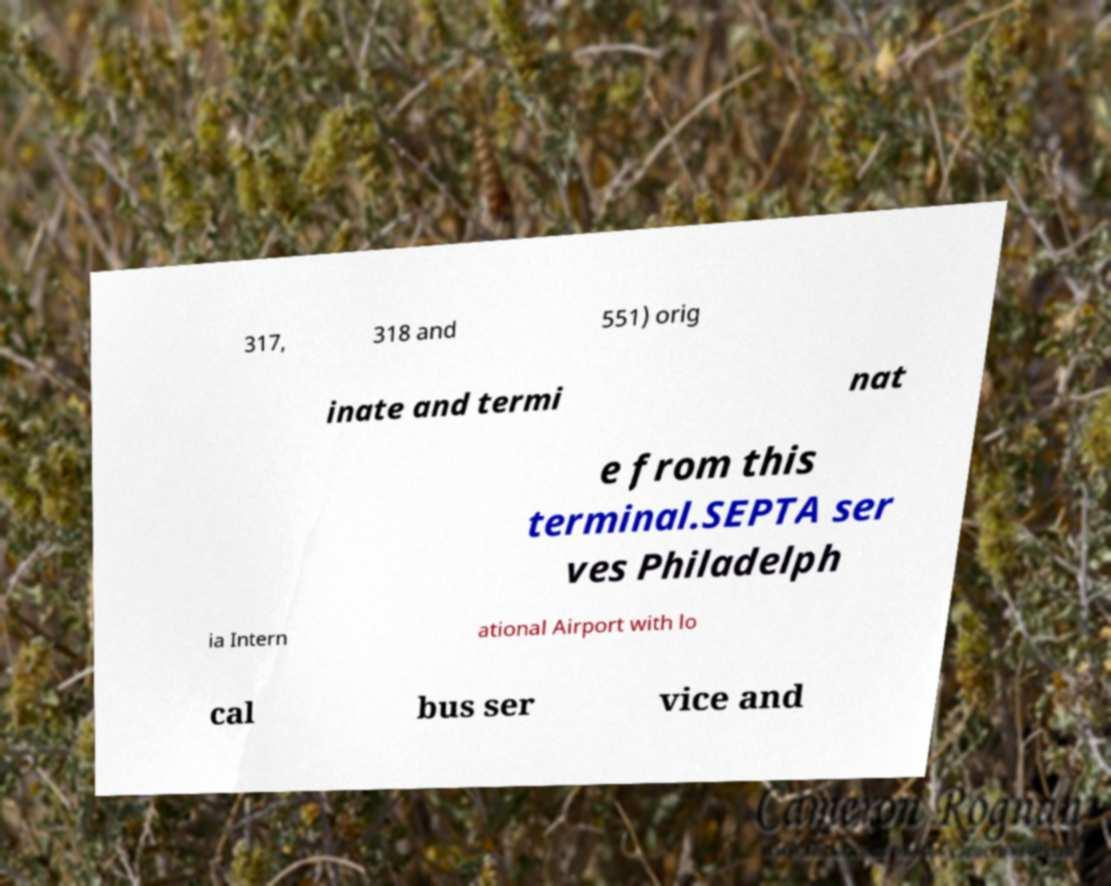Please read and relay the text visible in this image. What does it say? 317, 318 and 551) orig inate and termi nat e from this terminal.SEPTA ser ves Philadelph ia Intern ational Airport with lo cal bus ser vice and 